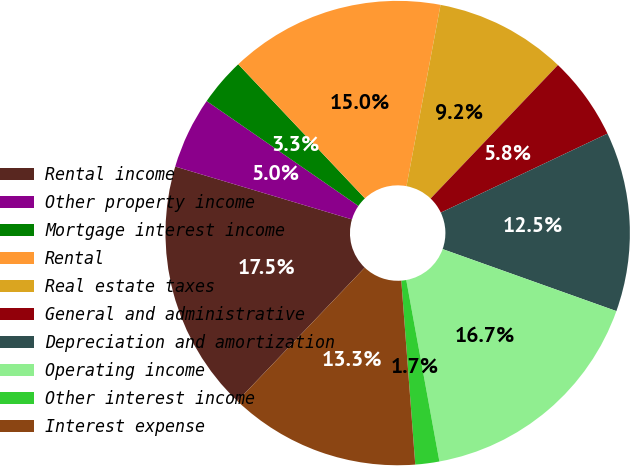Convert chart. <chart><loc_0><loc_0><loc_500><loc_500><pie_chart><fcel>Rental income<fcel>Other property income<fcel>Mortgage interest income<fcel>Rental<fcel>Real estate taxes<fcel>General and administrative<fcel>Depreciation and amortization<fcel>Operating income<fcel>Other interest income<fcel>Interest expense<nl><fcel>17.5%<fcel>5.0%<fcel>3.33%<fcel>15.0%<fcel>9.17%<fcel>5.83%<fcel>12.5%<fcel>16.67%<fcel>1.67%<fcel>13.33%<nl></chart> 